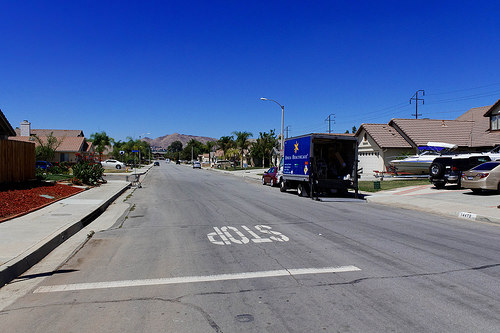<image>
Is the boat to the left of the car? Yes. From this viewpoint, the boat is positioned to the left side relative to the car. 